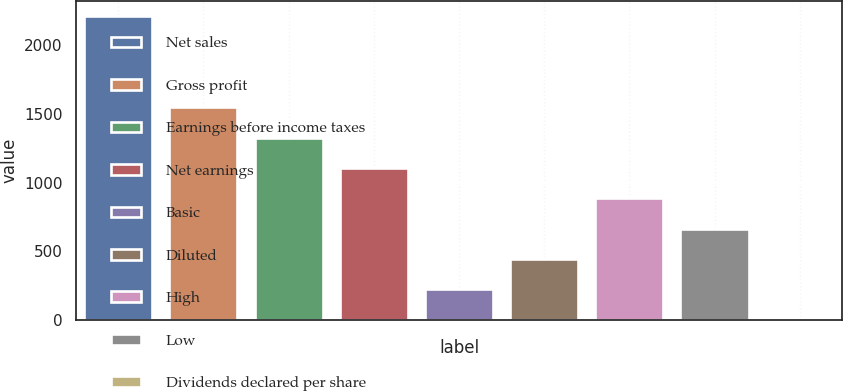Convert chart to OTSL. <chart><loc_0><loc_0><loc_500><loc_500><bar_chart><fcel>Net sales<fcel>Gross profit<fcel>Earnings before income taxes<fcel>Net earnings<fcel>Basic<fcel>Diluted<fcel>High<fcel>Low<fcel>Dividends declared per share<nl><fcel>2212<fcel>1548.46<fcel>1327.29<fcel>1106.12<fcel>221.44<fcel>442.61<fcel>884.95<fcel>663.78<fcel>0.27<nl></chart> 